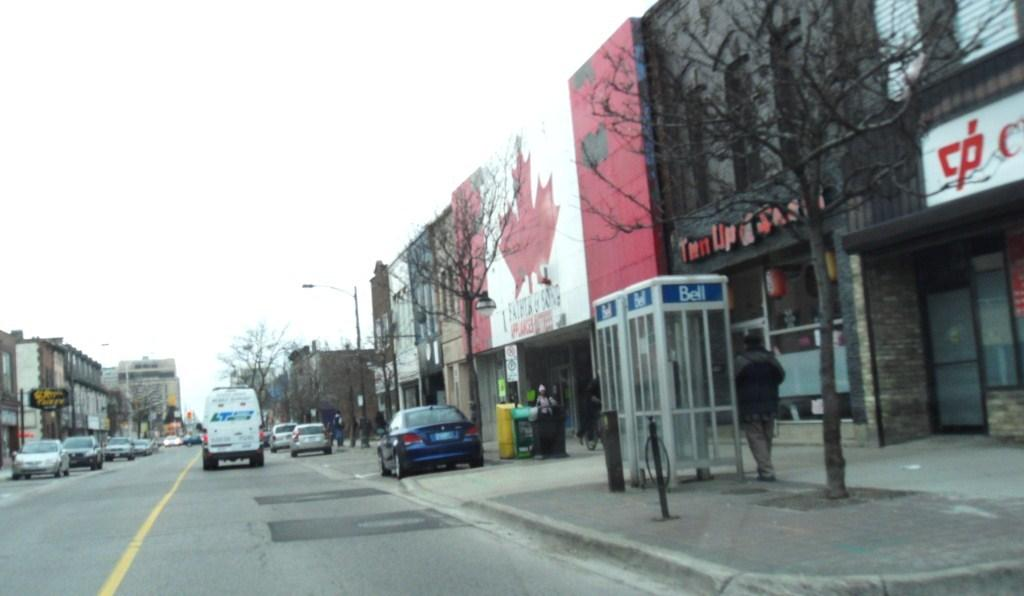What types of objects are present in the image? There are vehicles, stalls, buildings, boards, trees, and light poles in the image. Can you describe the setting of the image? The image features vehicles, stalls, and buildings, which suggests it might be a market or commercial area. What is the color of the sky in the image? The sky is white in color. How many types of objects can be seen in the image? There are seven types of objects present in the image: vehicles, stalls, buildings, boards, trees, light poles, and the sky. What type of blade can be seen being used by the street performer in the image? There is no street performer or blade present in the image. What is the street performer using the blade for in the image? There is no street performer or blade present in the image, so it is not possible to determine what the blade might be used for. 